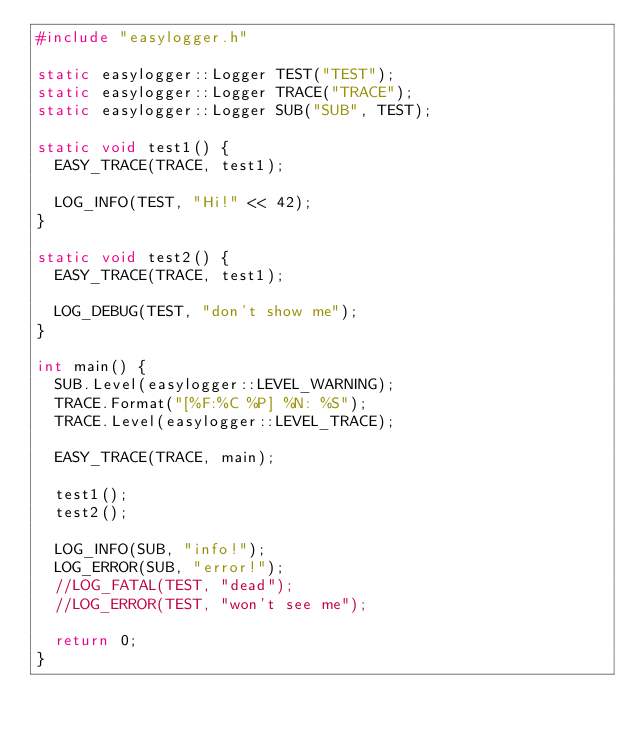Convert code to text. <code><loc_0><loc_0><loc_500><loc_500><_C++_>#include "easylogger.h"

static easylogger::Logger TEST("TEST");
static easylogger::Logger TRACE("TRACE");
static easylogger::Logger SUB("SUB", TEST);

static void test1() {
	EASY_TRACE(TRACE, test1);

	LOG_INFO(TEST, "Hi!" << 42);
}

static void test2() {
	EASY_TRACE(TRACE, test1);

	LOG_DEBUG(TEST, "don't show me");
}

int main() {
	SUB.Level(easylogger::LEVEL_WARNING);
	TRACE.Format("[%F:%C %P] %N: %S");
	TRACE.Level(easylogger::LEVEL_TRACE);

	EASY_TRACE(TRACE, main);

	test1();
	test2();

	LOG_INFO(SUB, "info!");
	LOG_ERROR(SUB, "error!");
	//LOG_FATAL(TEST, "dead");
	//LOG_ERROR(TEST, "won't see me");

	return 0;
}
</code> 